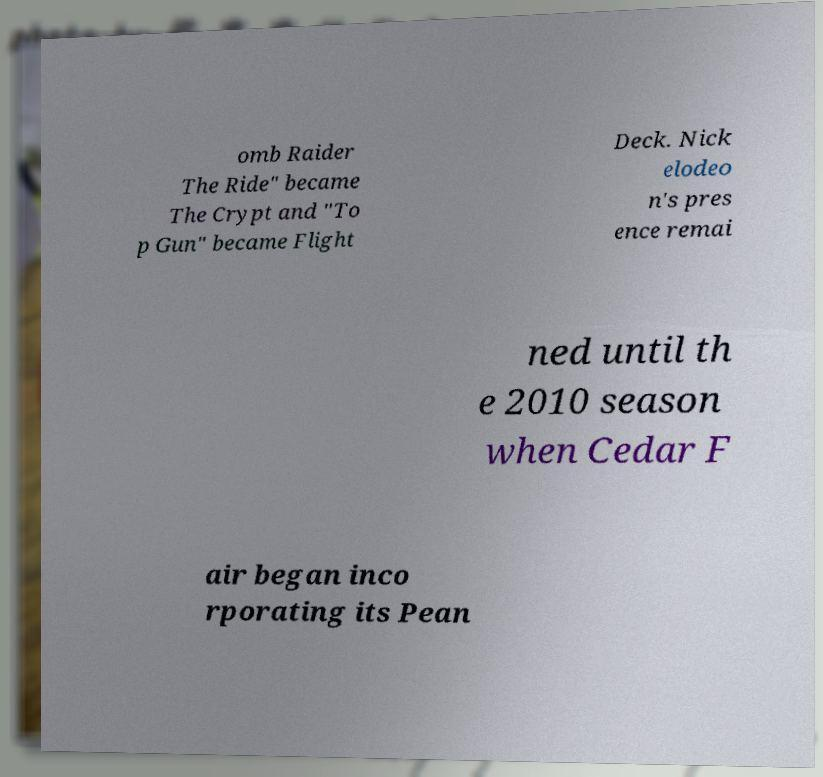For documentation purposes, I need the text within this image transcribed. Could you provide that? omb Raider The Ride" became The Crypt and "To p Gun" became Flight Deck. Nick elodeo n's pres ence remai ned until th e 2010 season when Cedar F air began inco rporating its Pean 